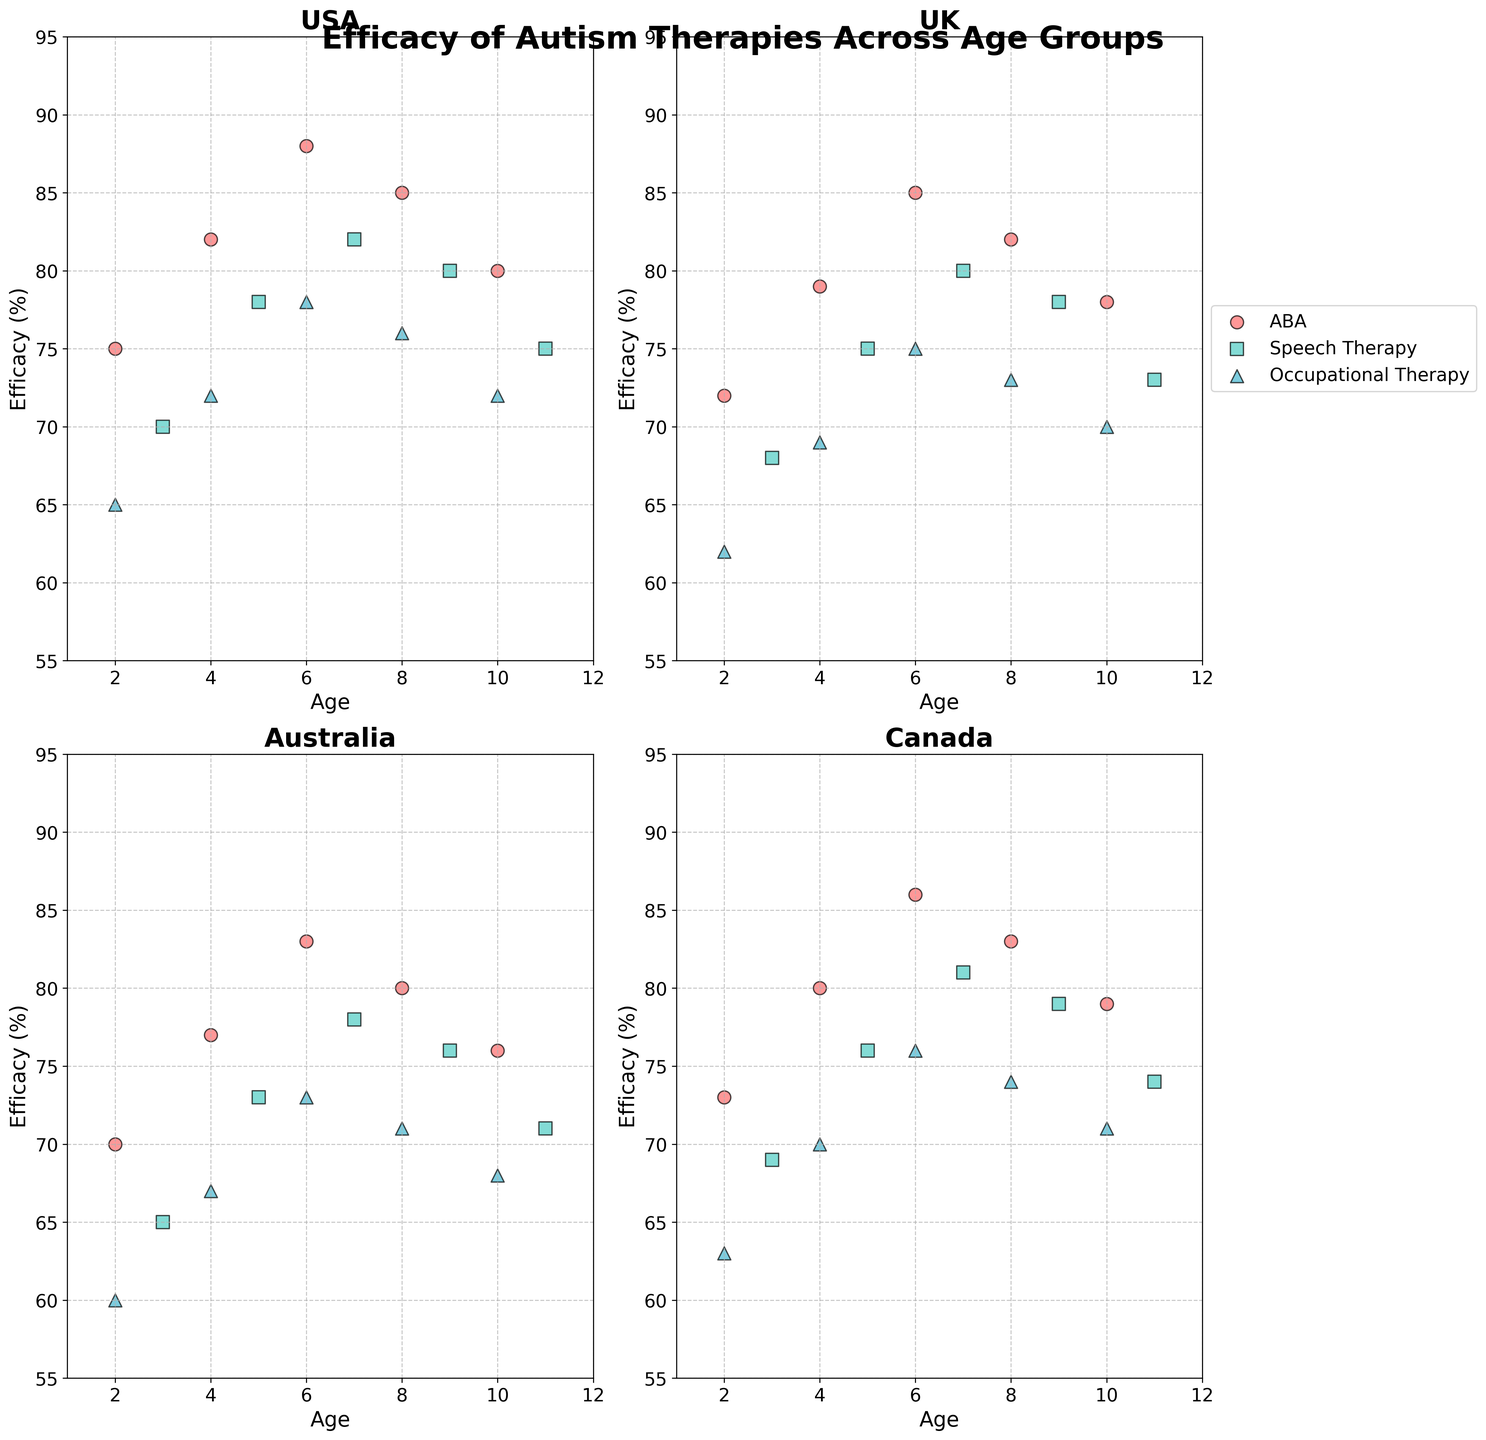What is the efficacy of ABA therapy for a 6-year-old in Canada compared to the same age group in the USA? To compare the efficacy, find the value for the 6-year-old group in both countries. For Canada, it's 86% and for the USA, it's 88%
Answer: USA: 88%, Canada: 86% Which country has higher efficacy for Speech Therapy at age 9, USA or Australia? Check the efficacy values for Speech Therapy at age 9 for both countries. USA shows 80% and Australia shows 76%. Therefore, the USA has higher efficacy.
Answer: USA What's the trend in efficacy for Occupational Therapy in the UK as children get older? To find the trend, observe the efficacy values in the UK for various ages: 62%, 69%, 75%, 73%, 70%. The values initially increase then slightly decrease after age 6.
Answer: Increasing initially, then decreasing Among all presented therapies and countries, which therapy's efficacy shows the most consistent values across ages? Consistent values imply less fluctuation. By observing the plots, ABA therapy shows relatively small fluctuations compared to others across all ages and countries.
Answer: ABA For a 4-year-old child, which has higher efficacy: Occupational Therapy in Australia or Speech Therapy in Canada? Check the efficacy values for a 4-year-old in both therapies and countries: Occupational Therapy in Australia is 67%, and Speech Therapy in Canada is 76%.
Answer: Speech Therapy in Canada What is the difference in efficacy between ABA therapy and Occupational Therapy for a 10-year-old in the UK? Find the efficacy values: ABA therapy is 78% and Occupational Therapy is 70%. The difference is 78% - 70% = 8%.
Answer: 8% Comparing the therapy with the highest efficacy at age 7, which country leads in that age group? At age 7, compare the highest efficacy for all therapies in each country. ABA in most countries shows the highest efficacy: USA - 88%, UK - 85%, Australia - 83%, Canada - 86%. USA has the highest at 88%.
Answer: USA Between ages 2 to 10, does Speech Therapy in Canada ever surpass the efficacy of ABA therapy? Look at the efficacy curve for Speech Therapy and ABA in Canada. ABA always has higher efficacy scores compared to Speech Therapy in all corresponding age points.
Answer: No Which age group shows the highest efficacy for ABA therapy in the USA? Review the efficacy values for ABA therapy in the USA: 2 years - 75%, 4 years - 82%, 6 years - 88%, 8 years - 85%, 10 years - 80%. The highest is 88% at age 6.
Answer: 6 years If comparing Occupational Therapy between age groups 4 and 6 across all countries, what is the average increase in efficacy? Sum the difference in efficacy between ages 4 and 6 for all countries: USA (72 to 78), UK (69 to 75), Australia (67 to 73), Canada (70 to 76). Differences: 6%, 6%, 6%, 6%. Average difference: (6 + 6 + 6 + 6)/4 = 6%.
Answer: 6% 